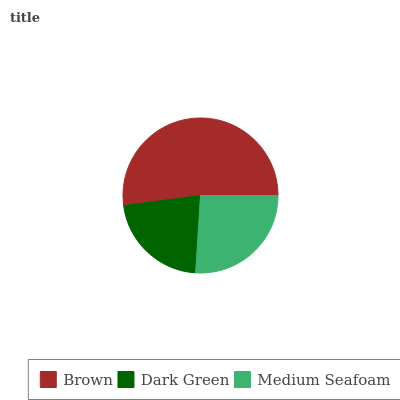Is Dark Green the minimum?
Answer yes or no. Yes. Is Brown the maximum?
Answer yes or no. Yes. Is Medium Seafoam the minimum?
Answer yes or no. No. Is Medium Seafoam the maximum?
Answer yes or no. No. Is Medium Seafoam greater than Dark Green?
Answer yes or no. Yes. Is Dark Green less than Medium Seafoam?
Answer yes or no. Yes. Is Dark Green greater than Medium Seafoam?
Answer yes or no. No. Is Medium Seafoam less than Dark Green?
Answer yes or no. No. Is Medium Seafoam the high median?
Answer yes or no. Yes. Is Medium Seafoam the low median?
Answer yes or no. Yes. Is Dark Green the high median?
Answer yes or no. No. Is Brown the low median?
Answer yes or no. No. 